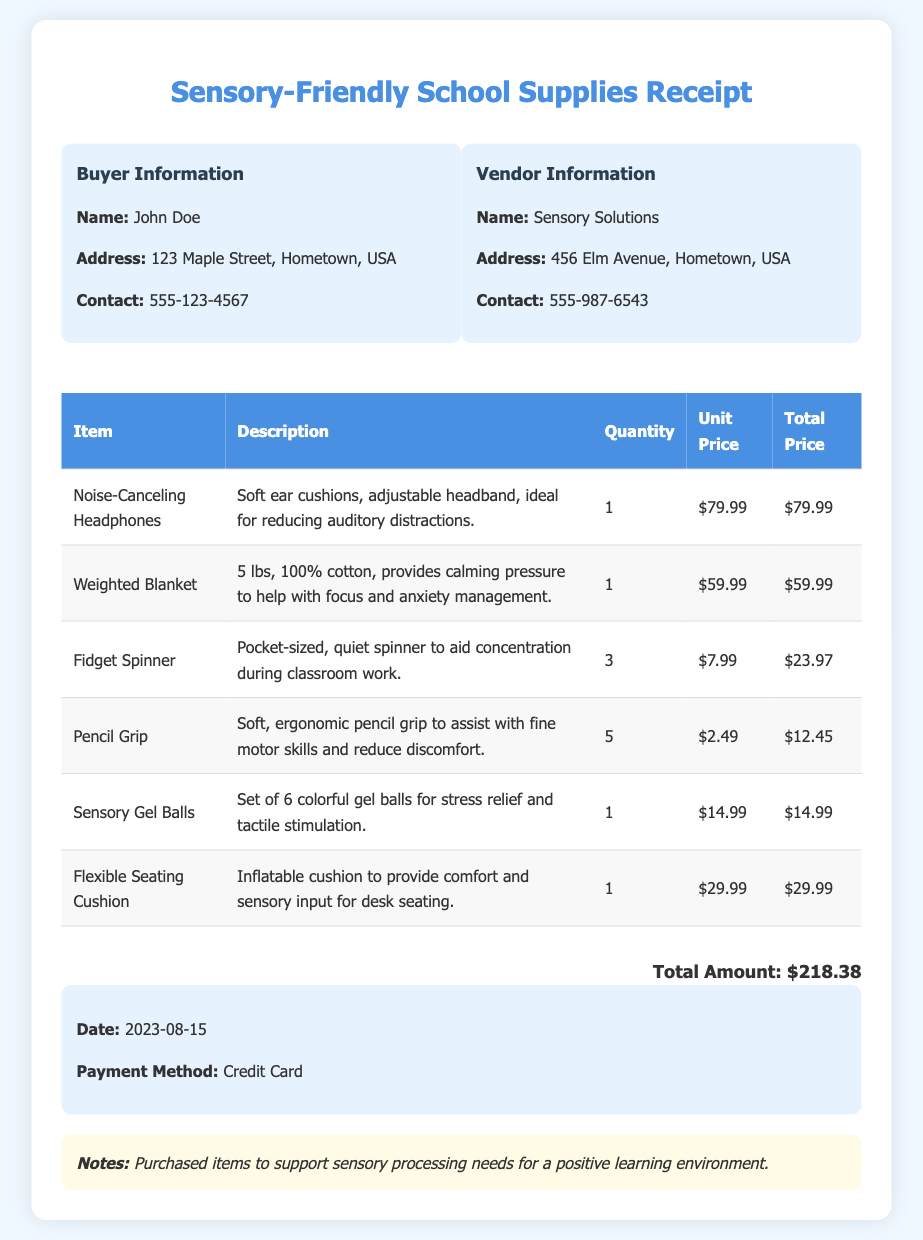What is the total amount? The total amount is explicitly stated in the document, summarizing the costs of all items purchased.
Answer: $218.38 Who is the buyer? The buyer's name is provided at the beginning of the document under buyer information.
Answer: John Doe What is the payment method used? The document specifies the payment method in the information box.
Answer: Credit Card How many units of the fidget spinner were purchased? The quantity of the fidget spinner is detailed in the table of items purchased.
Answer: 3 What is the description of the noise-canceling headphones? The description of the noise-canceling headphones is provided in the table under the description column.
Answer: Soft ear cushions, adjustable headband, ideal for reducing auditory distractions What type of item is the weighted blanket? The weighted blanket is categorized as a calming product in the context of sensory processing needs.
Answer: Weighted Blanket What date was the purchase made? The purchase date is located in the information box on the document.
Answer: 2023-08-15 Which vendor sold the school supplies? The name of the vendor is specified in the vendor information section of the document.
Answer: Sensory Solutions 